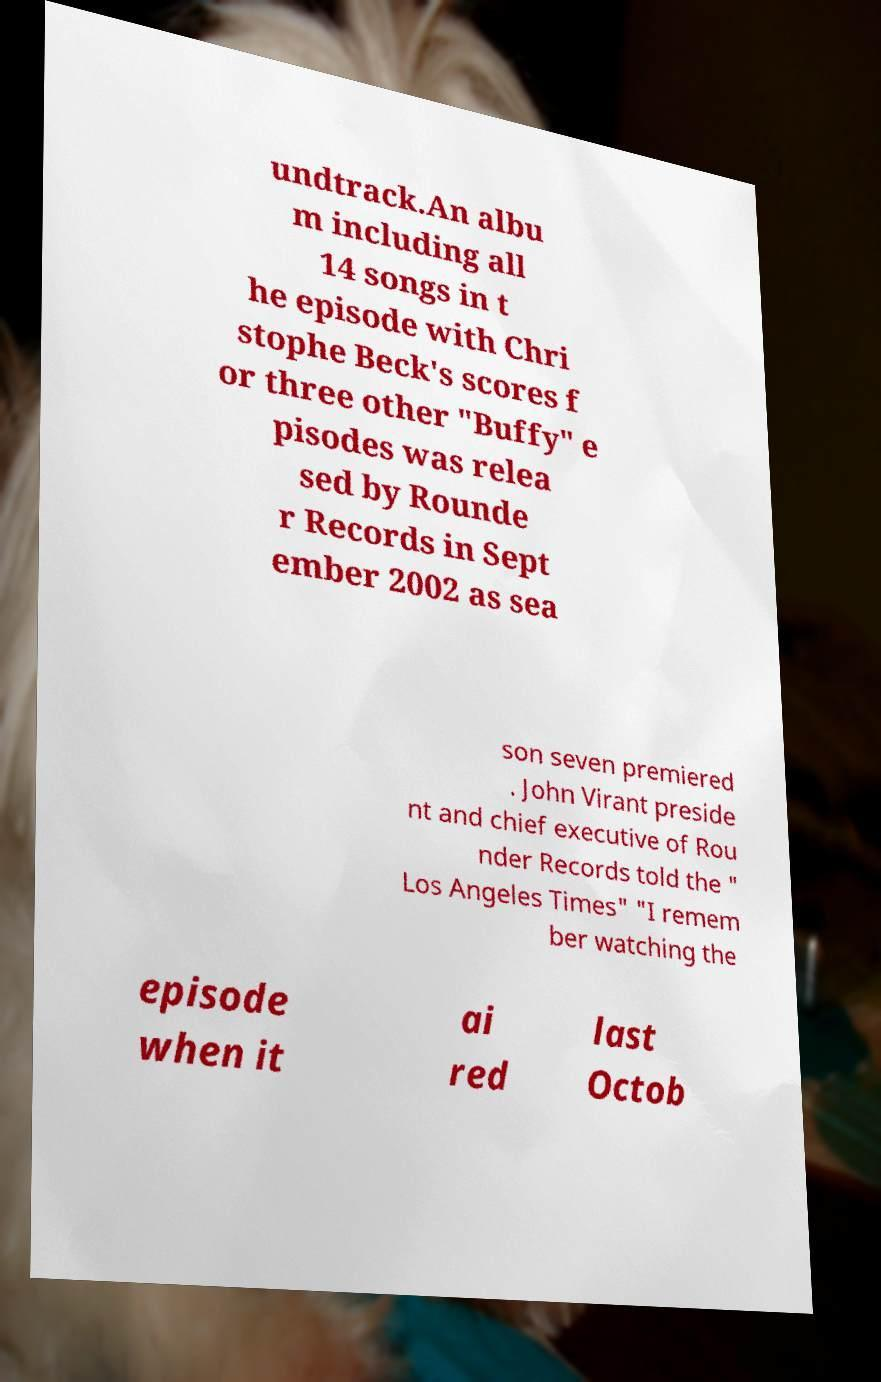Please identify and transcribe the text found in this image. undtrack.An albu m including all 14 songs in t he episode with Chri stophe Beck's scores f or three other "Buffy" e pisodes was relea sed by Rounde r Records in Sept ember 2002 as sea son seven premiered . John Virant preside nt and chief executive of Rou nder Records told the " Los Angeles Times" "I remem ber watching the episode when it ai red last Octob 